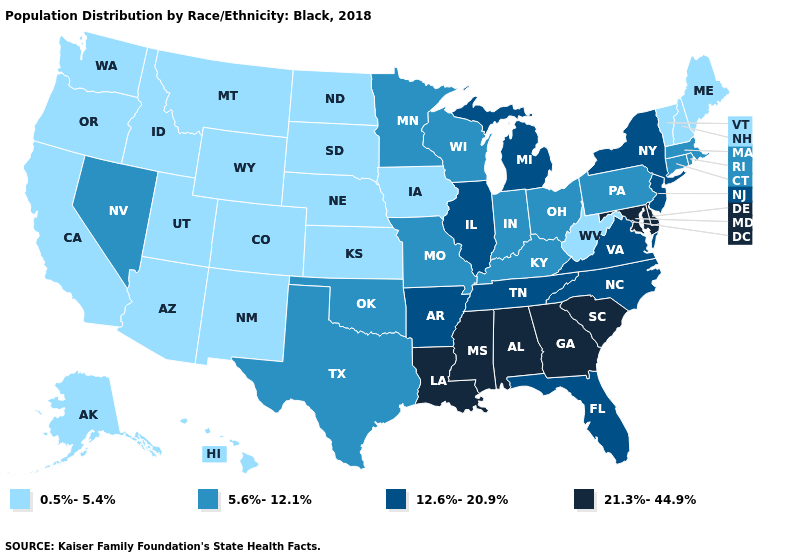Does the first symbol in the legend represent the smallest category?
Answer briefly. Yes. What is the highest value in states that border Vermont?
Give a very brief answer. 12.6%-20.9%. Name the states that have a value in the range 21.3%-44.9%?
Be succinct. Alabama, Delaware, Georgia, Louisiana, Maryland, Mississippi, South Carolina. Does Kentucky have the highest value in the South?
Short answer required. No. Among the states that border Oregon , which have the highest value?
Quick response, please. Nevada. What is the value of Montana?
Be succinct. 0.5%-5.4%. Name the states that have a value in the range 21.3%-44.9%?
Concise answer only. Alabama, Delaware, Georgia, Louisiana, Maryland, Mississippi, South Carolina. Does West Virginia have the lowest value in the South?
Keep it brief. Yes. Does the map have missing data?
Concise answer only. No. Which states hav the highest value in the West?
Keep it brief. Nevada. Is the legend a continuous bar?
Quick response, please. No. Does Rhode Island have the lowest value in the Northeast?
Be succinct. No. Does Massachusetts have a lower value than New Hampshire?
Be succinct. No. How many symbols are there in the legend?
Answer briefly. 4. 